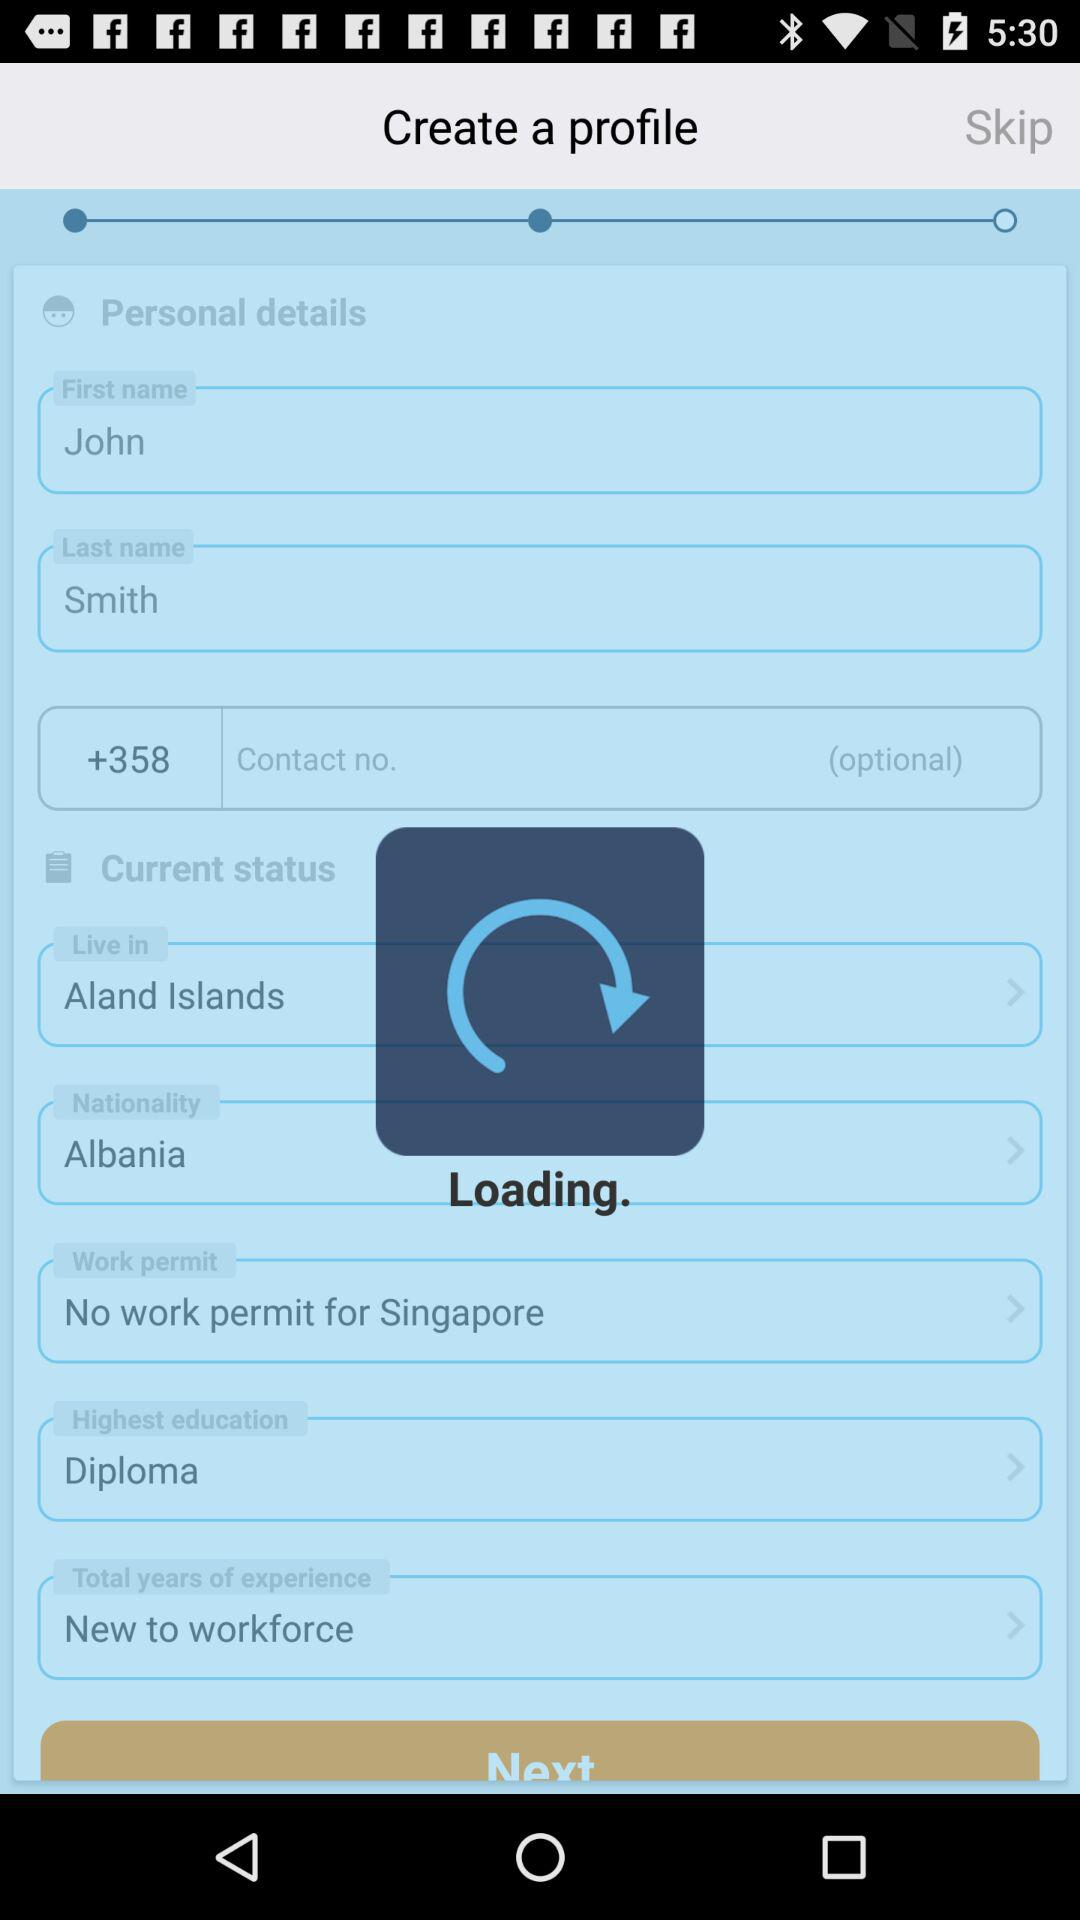What is the highest education? The highest education is a diploma. 